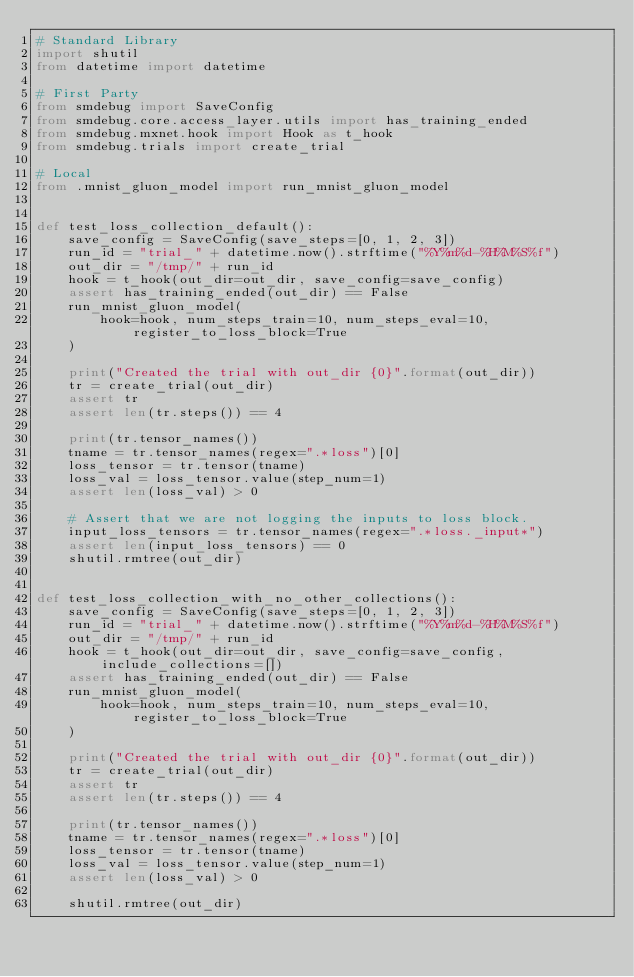<code> <loc_0><loc_0><loc_500><loc_500><_Python_># Standard Library
import shutil
from datetime import datetime

# First Party
from smdebug import SaveConfig
from smdebug.core.access_layer.utils import has_training_ended
from smdebug.mxnet.hook import Hook as t_hook
from smdebug.trials import create_trial

# Local
from .mnist_gluon_model import run_mnist_gluon_model


def test_loss_collection_default():
    save_config = SaveConfig(save_steps=[0, 1, 2, 3])
    run_id = "trial_" + datetime.now().strftime("%Y%m%d-%H%M%S%f")
    out_dir = "/tmp/" + run_id
    hook = t_hook(out_dir=out_dir, save_config=save_config)
    assert has_training_ended(out_dir) == False
    run_mnist_gluon_model(
        hook=hook, num_steps_train=10, num_steps_eval=10, register_to_loss_block=True
    )

    print("Created the trial with out_dir {0}".format(out_dir))
    tr = create_trial(out_dir)
    assert tr
    assert len(tr.steps()) == 4

    print(tr.tensor_names())
    tname = tr.tensor_names(regex=".*loss")[0]
    loss_tensor = tr.tensor(tname)
    loss_val = loss_tensor.value(step_num=1)
    assert len(loss_val) > 0

    # Assert that we are not logging the inputs to loss block.
    input_loss_tensors = tr.tensor_names(regex=".*loss._input*")
    assert len(input_loss_tensors) == 0
    shutil.rmtree(out_dir)


def test_loss_collection_with_no_other_collections():
    save_config = SaveConfig(save_steps=[0, 1, 2, 3])
    run_id = "trial_" + datetime.now().strftime("%Y%m%d-%H%M%S%f")
    out_dir = "/tmp/" + run_id
    hook = t_hook(out_dir=out_dir, save_config=save_config, include_collections=[])
    assert has_training_ended(out_dir) == False
    run_mnist_gluon_model(
        hook=hook, num_steps_train=10, num_steps_eval=10, register_to_loss_block=True
    )

    print("Created the trial with out_dir {0}".format(out_dir))
    tr = create_trial(out_dir)
    assert tr
    assert len(tr.steps()) == 4

    print(tr.tensor_names())
    tname = tr.tensor_names(regex=".*loss")[0]
    loss_tensor = tr.tensor(tname)
    loss_val = loss_tensor.value(step_num=1)
    assert len(loss_val) > 0

    shutil.rmtree(out_dir)
</code> 